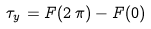Convert formula to latex. <formula><loc_0><loc_0><loc_500><loc_500>\tau _ { y } = F ( 2 \, \pi ) - F ( 0 )</formula> 